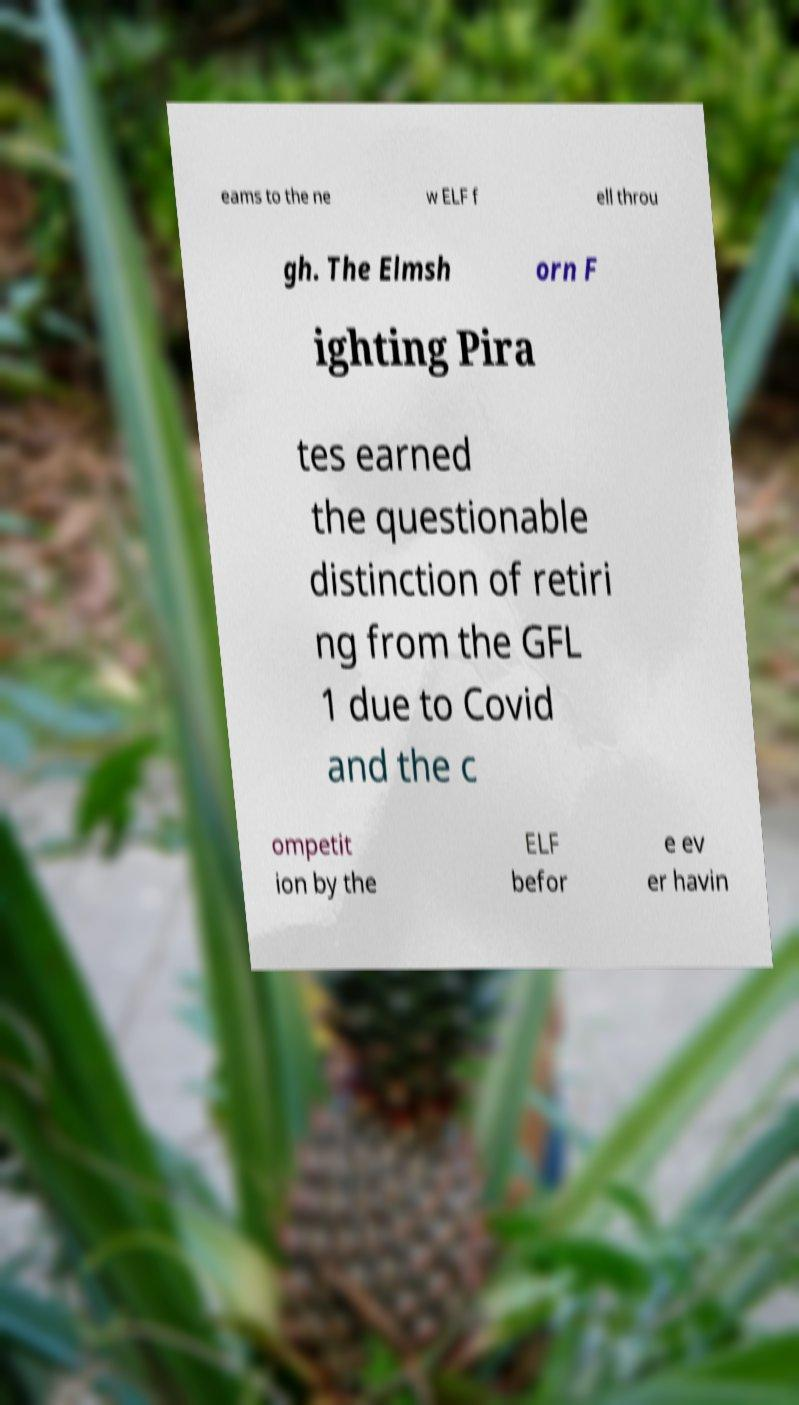What messages or text are displayed in this image? I need them in a readable, typed format. eams to the ne w ELF f ell throu gh. The Elmsh orn F ighting Pira tes earned the questionable distinction of retiri ng from the GFL 1 due to Covid and the c ompetit ion by the ELF befor e ev er havin 